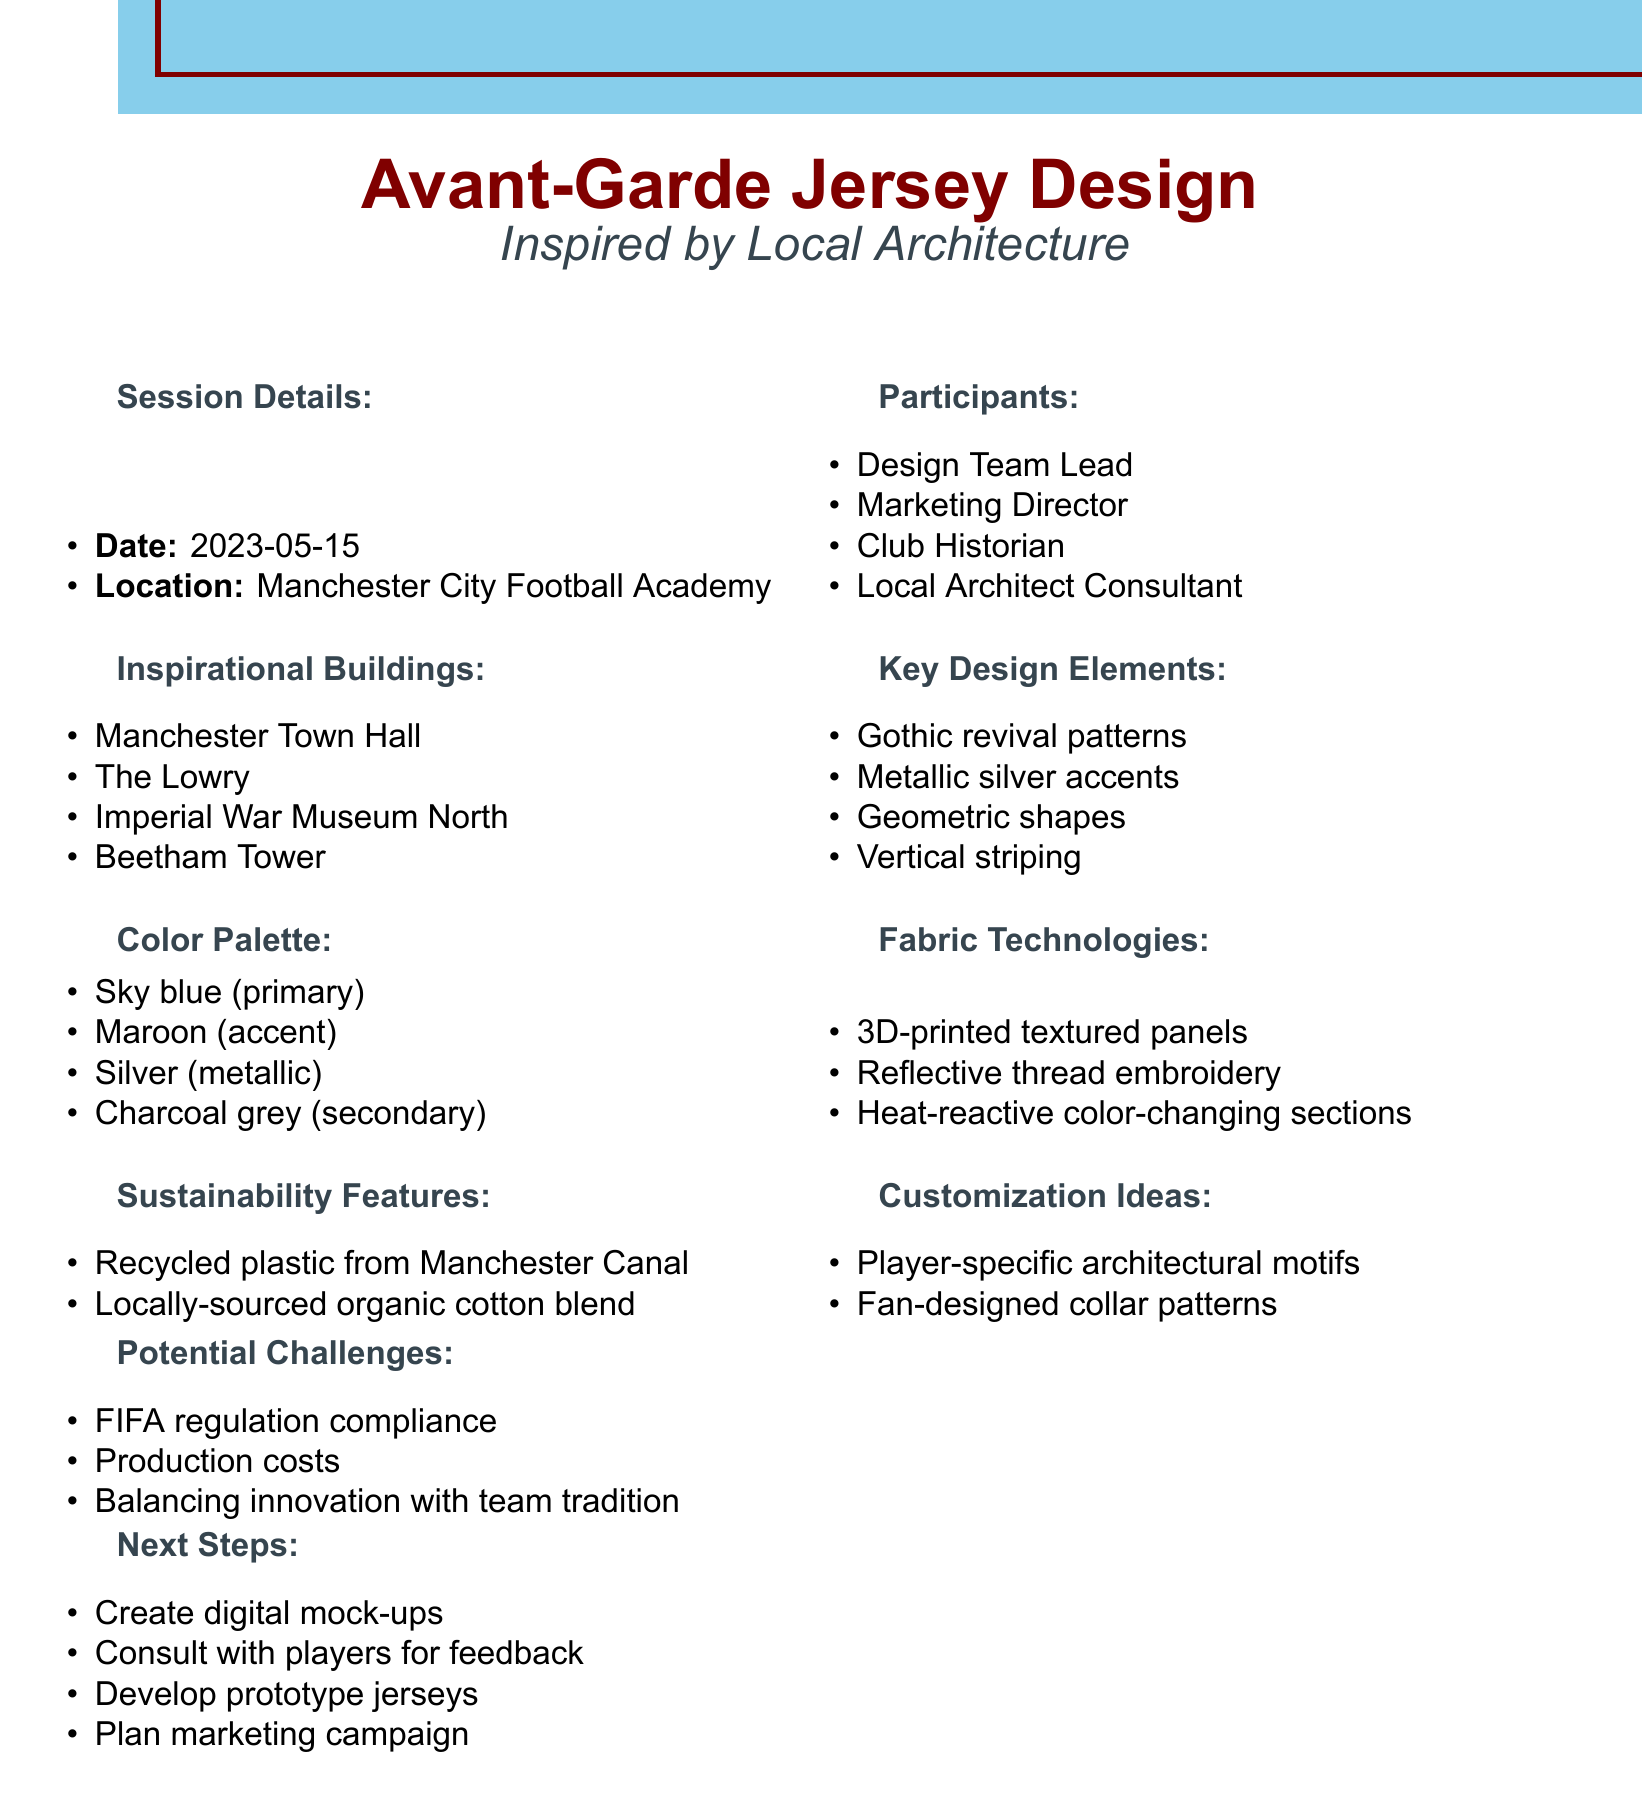What is the date of the brainstorming session? The date can be found in the session details section of the document.
Answer: 2023-05-15 Where did the brainstorming session take place? The location is specified in the session details part of the document.
Answer: Manchester City Football Academy Who is one of the participants in the session? The list of participants can be found in the relevant section of the document.
Answer: Design Team Lead What are two elements of the key design? The key design elements are listed in their own section, requiring identification of any two.
Answer: Gothic revival patterns, Metallic silver accents What is the primary color in the color palette? The color palette provides the main colors used in the jersey designs, identifying the primary one is requested.
Answer: Sky blue What sustainability feature involves local resources? The sustainability features mention materials sourced locally, requiring identification of one.
Answer: Locally-sourced organic cotton blend What is one potential challenge mentioned in the notes? The potential challenges are outlined in a specific section of the document, requiring a singular identification.
Answer: FIFA regulation compliance What next step involves player input? The next steps section includes a specific action that requires player feedback.
Answer: Consult with players for feedback 